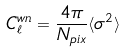<formula> <loc_0><loc_0><loc_500><loc_500>C _ { \ell } ^ { w n } = \frac { 4 \pi } { N _ { p i x } } \langle \sigma ^ { 2 } \rangle</formula> 